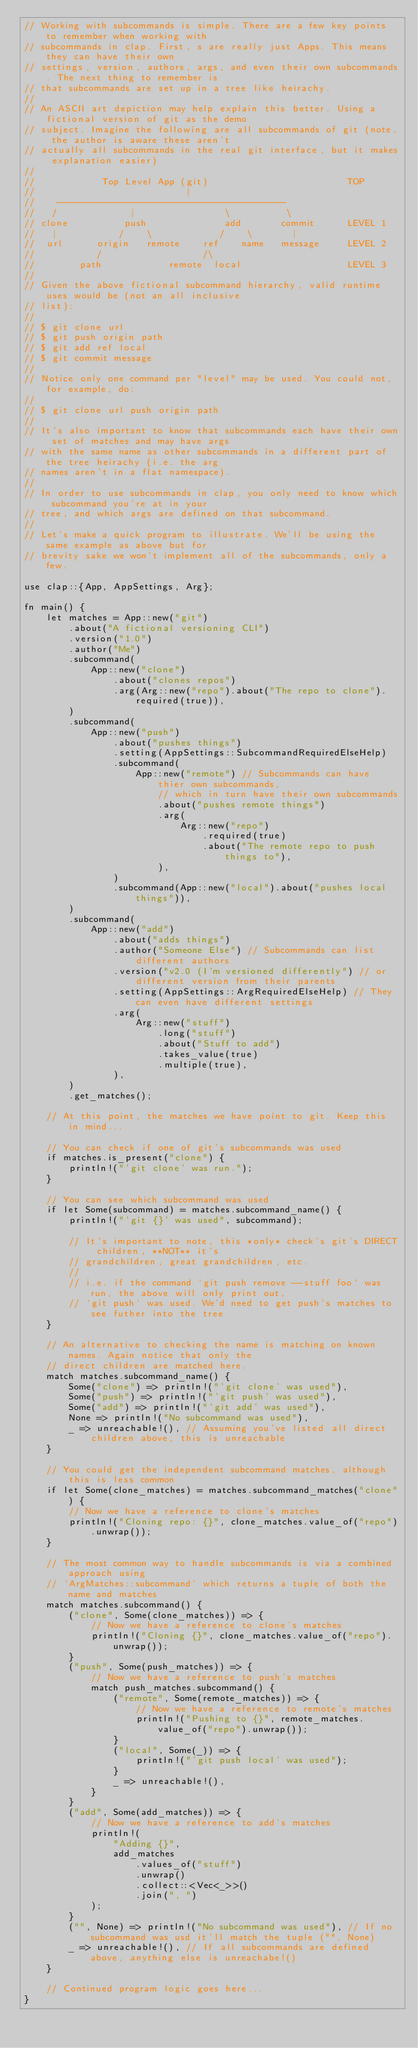<code> <loc_0><loc_0><loc_500><loc_500><_Rust_>// Working with subcommands is simple. There are a few key points to remember when working with
// subcommands in clap. First, s are really just Apps. This means they can have their own
// settings, version, authors, args, and even their own subcommands. The next thing to remember is
// that subcommands are set up in a tree like heirachy.
//
// An ASCII art depiction may help explain this better. Using a fictional version of git as the demo
// subject. Imagine the following are all subcommands of git (note, the author is aware these aren't
// actually all subcommands in the real git interface, but it makes explanation easier)
//
//            Top Level App (git)                         TOP
//                           |
//    -----------------------------------------
//   /             |                \          \
// clone          push              add       commit      LEVEL 1
//   |           /    \            /    \       |
//  url      origin   remote    ref    name   message     LEVEL 2
//           /                  /\
//        path            remote  local                   LEVEL 3
//
// Given the above fictional subcommand hierarchy, valid runtime uses would be (not an all inclusive
// list):
//
// $ git clone url
// $ git push origin path
// $ git add ref local
// $ git commit message
//
// Notice only one command per "level" may be used. You could not, for example, do:
//
// $ git clone url push origin path
//
// It's also important to know that subcommands each have their own set of matches and may have args
// with the same name as other subcommands in a different part of the tree heirachy (i.e. the arg
// names aren't in a flat namespace).
//
// In order to use subcommands in clap, you only need to know which subcommand you're at in your
// tree, and which args are defined on that subcommand.
//
// Let's make a quick program to illustrate. We'll be using the same example as above but for
// brevity sake we won't implement all of the subcommands, only a few.

use clap::{App, AppSettings, Arg};

fn main() {
    let matches = App::new("git")
        .about("A fictional versioning CLI")
        .version("1.0")
        .author("Me")
        .subcommand(
            App::new("clone")
                .about("clones repos")
                .arg(Arg::new("repo").about("The repo to clone").required(true)),
        )
        .subcommand(
            App::new("push")
                .about("pushes things")
                .setting(AppSettings::SubcommandRequiredElseHelp)
                .subcommand(
                    App::new("remote") // Subcommands can have thier own subcommands,
                        // which in turn have their own subcommands
                        .about("pushes remote things")
                        .arg(
                            Arg::new("repo")
                                .required(true)
                                .about("The remote repo to push things to"),
                        ),
                )
                .subcommand(App::new("local").about("pushes local things")),
        )
        .subcommand(
            App::new("add")
                .about("adds things")
                .author("Someone Else") // Subcommands can list different authors
                .version("v2.0 (I'm versioned differently") // or different version from their parents
                .setting(AppSettings::ArgRequiredElseHelp) // They can even have different settings
                .arg(
                    Arg::new("stuff")
                        .long("stuff")
                        .about("Stuff to add")
                        .takes_value(true)
                        .multiple(true),
                ),
        )
        .get_matches();

    // At this point, the matches we have point to git. Keep this in mind...

    // You can check if one of git's subcommands was used
    if matches.is_present("clone") {
        println!("'git clone' was run.");
    }

    // You can see which subcommand was used
    if let Some(subcommand) = matches.subcommand_name() {
        println!("'git {}' was used", subcommand);

        // It's important to note, this *only* check's git's DIRECT children, **NOT** it's
        // grandchildren, great grandchildren, etc.
        //
        // i.e. if the command `git push remove --stuff foo` was run, the above will only print out,
        // `git push` was used. We'd need to get push's matches to see futher into the tree
    }

    // An alternative to checking the name is matching on known names. Again notice that only the
    // direct children are matched here.
    match matches.subcommand_name() {
        Some("clone") => println!("'git clone' was used"),
        Some("push") => println!("'git push' was used"),
        Some("add") => println!("'git add' was used"),
        None => println!("No subcommand was used"),
        _ => unreachable!(), // Assuming you've listed all direct children above, this is unreachable
    }

    // You could get the independent subcommand matches, although this is less common
    if let Some(clone_matches) = matches.subcommand_matches("clone") {
        // Now we have a reference to clone's matches
        println!("Cloning repo: {}", clone_matches.value_of("repo").unwrap());
    }

    // The most common way to handle subcommands is via a combined approach using
    // `ArgMatches::subcommand` which returns a tuple of both the name and matches
    match matches.subcommand() {
        ("clone", Some(clone_matches)) => {
            // Now we have a reference to clone's matches
            println!("Cloning {}", clone_matches.value_of("repo").unwrap());
        }
        ("push", Some(push_matches)) => {
            // Now we have a reference to push's matches
            match push_matches.subcommand() {
                ("remote", Some(remote_matches)) => {
                    // Now we have a reference to remote's matches
                    println!("Pushing to {}", remote_matches.value_of("repo").unwrap());
                }
                ("local", Some(_)) => {
                    println!("'git push local' was used");
                }
                _ => unreachable!(),
            }
        }
        ("add", Some(add_matches)) => {
            // Now we have a reference to add's matches
            println!(
                "Adding {}",
                add_matches
                    .values_of("stuff")
                    .unwrap()
                    .collect::<Vec<_>>()
                    .join(", ")
            );
        }
        ("", None) => println!("No subcommand was used"), // If no subcommand was usd it'll match the tuple ("", None)
        _ => unreachable!(), // If all subcommands are defined above, anything else is unreachabe!()
    }

    // Continued program logic goes here...
}
</code> 